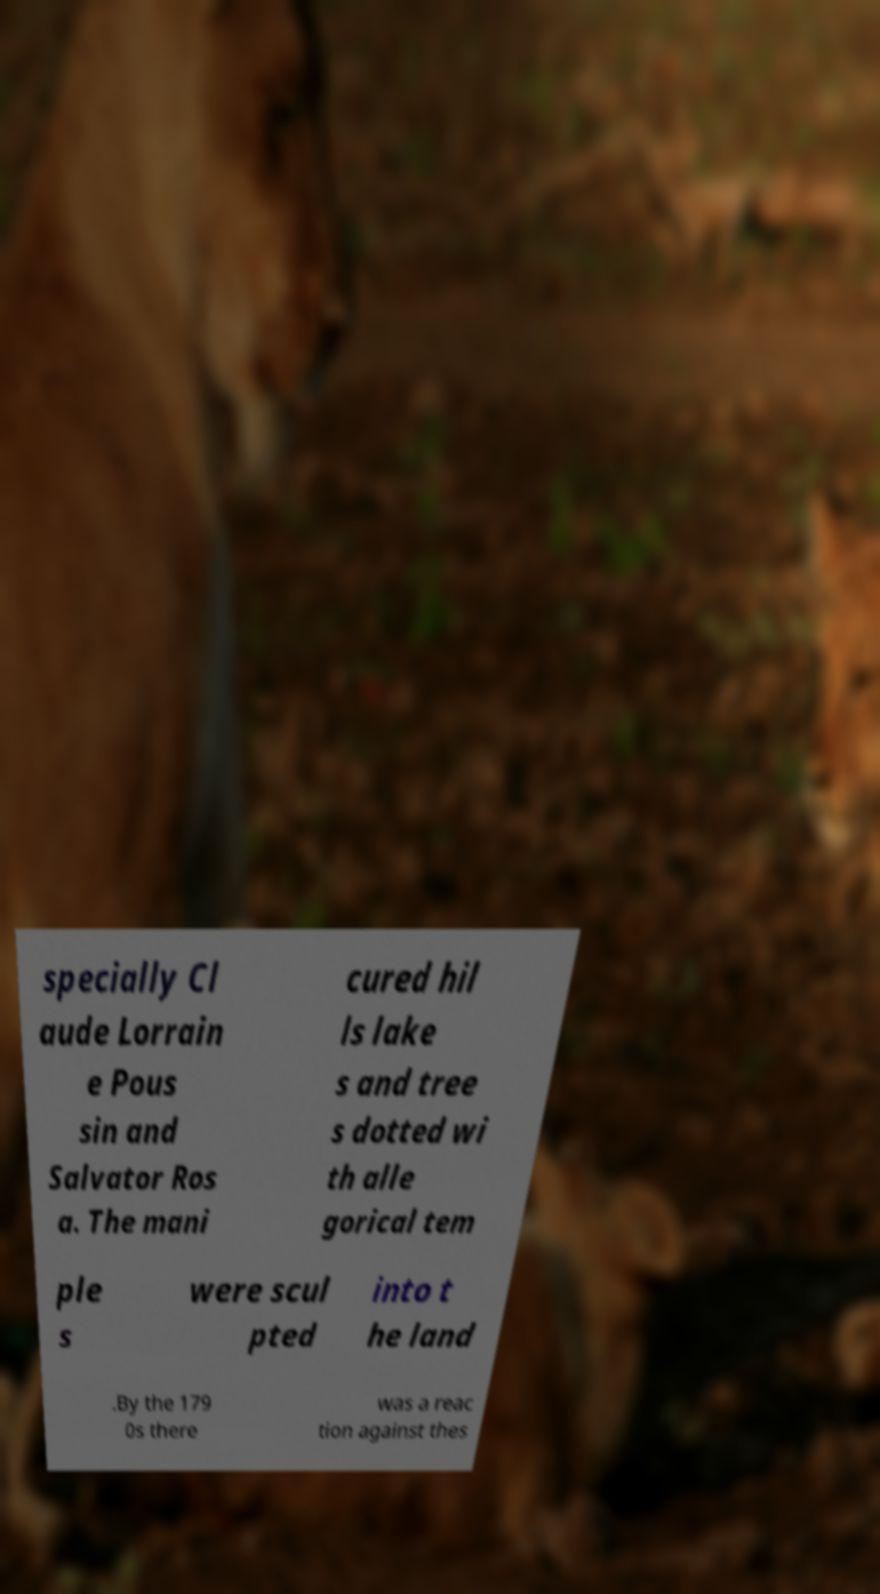I need the written content from this picture converted into text. Can you do that? specially Cl aude Lorrain e Pous sin and Salvator Ros a. The mani cured hil ls lake s and tree s dotted wi th alle gorical tem ple s were scul pted into t he land .By the 179 0s there was a reac tion against thes 